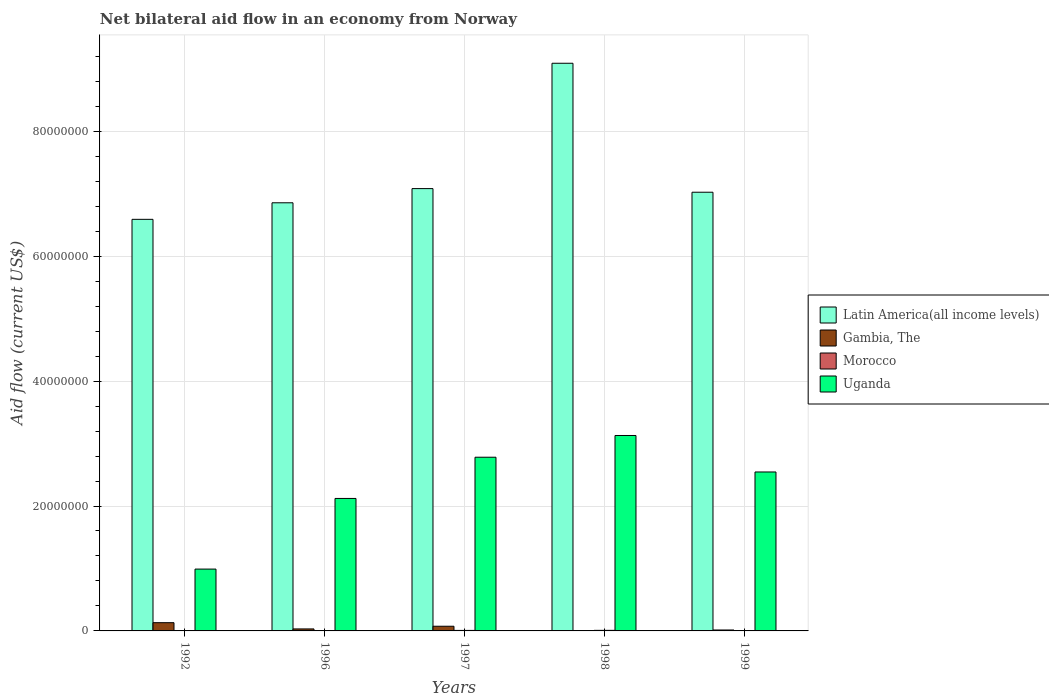How many different coloured bars are there?
Make the answer very short. 4. How many bars are there on the 1st tick from the left?
Provide a short and direct response. 4. How many bars are there on the 2nd tick from the right?
Give a very brief answer. 3. What is the label of the 4th group of bars from the left?
Offer a terse response. 1998. What is the net bilateral aid flow in Uganda in 1996?
Your answer should be compact. 2.12e+07. Across all years, what is the maximum net bilateral aid flow in Gambia, The?
Provide a succinct answer. 1.32e+06. Across all years, what is the minimum net bilateral aid flow in Uganda?
Make the answer very short. 9.90e+06. In which year was the net bilateral aid flow in Uganda maximum?
Make the answer very short. 1998. What is the total net bilateral aid flow in Uganda in the graph?
Provide a short and direct response. 1.16e+08. What is the difference between the net bilateral aid flow in Uganda in 1992 and that in 1996?
Offer a very short reply. -1.13e+07. What is the difference between the net bilateral aid flow in Latin America(all income levels) in 1998 and the net bilateral aid flow in Gambia, The in 1996?
Offer a very short reply. 9.06e+07. What is the average net bilateral aid flow in Gambia, The per year?
Provide a short and direct response. 5.08e+05. In the year 1996, what is the difference between the net bilateral aid flow in Uganda and net bilateral aid flow in Latin America(all income levels)?
Your answer should be compact. -4.73e+07. In how many years, is the net bilateral aid flow in Gambia, The greater than 80000000 US$?
Give a very brief answer. 0. What is the ratio of the net bilateral aid flow in Latin America(all income levels) in 1996 to that in 1998?
Offer a very short reply. 0.75. Is the difference between the net bilateral aid flow in Uganda in 1996 and 1999 greater than the difference between the net bilateral aid flow in Latin America(all income levels) in 1996 and 1999?
Your answer should be compact. No. What is the difference between the highest and the second highest net bilateral aid flow in Uganda?
Make the answer very short. 3.48e+06. What is the difference between the highest and the lowest net bilateral aid flow in Morocco?
Your answer should be very brief. 6.00e+04. In how many years, is the net bilateral aid flow in Latin America(all income levels) greater than the average net bilateral aid flow in Latin America(all income levels) taken over all years?
Your response must be concise. 1. Is the sum of the net bilateral aid flow in Morocco in 1996 and 1998 greater than the maximum net bilateral aid flow in Gambia, The across all years?
Make the answer very short. No. Is it the case that in every year, the sum of the net bilateral aid flow in Gambia, The and net bilateral aid flow in Morocco is greater than the net bilateral aid flow in Latin America(all income levels)?
Make the answer very short. No. How many years are there in the graph?
Keep it short and to the point. 5. Does the graph contain any zero values?
Offer a very short reply. Yes. Where does the legend appear in the graph?
Keep it short and to the point. Center right. What is the title of the graph?
Give a very brief answer. Net bilateral aid flow in an economy from Norway. What is the label or title of the X-axis?
Your answer should be very brief. Years. What is the Aid flow (current US$) of Latin America(all income levels) in 1992?
Offer a very short reply. 6.59e+07. What is the Aid flow (current US$) in Gambia, The in 1992?
Ensure brevity in your answer.  1.32e+06. What is the Aid flow (current US$) of Uganda in 1992?
Your answer should be very brief. 9.90e+06. What is the Aid flow (current US$) of Latin America(all income levels) in 1996?
Your answer should be compact. 6.86e+07. What is the Aid flow (current US$) in Uganda in 1996?
Your response must be concise. 2.12e+07. What is the Aid flow (current US$) of Latin America(all income levels) in 1997?
Provide a short and direct response. 7.08e+07. What is the Aid flow (current US$) of Gambia, The in 1997?
Provide a short and direct response. 7.50e+05. What is the Aid flow (current US$) of Uganda in 1997?
Your response must be concise. 2.78e+07. What is the Aid flow (current US$) of Latin America(all income levels) in 1998?
Your answer should be very brief. 9.09e+07. What is the Aid flow (current US$) in Gambia, The in 1998?
Give a very brief answer. 0. What is the Aid flow (current US$) of Morocco in 1998?
Give a very brief answer. 9.00e+04. What is the Aid flow (current US$) of Uganda in 1998?
Offer a very short reply. 3.13e+07. What is the Aid flow (current US$) of Latin America(all income levels) in 1999?
Offer a terse response. 7.02e+07. What is the Aid flow (current US$) of Uganda in 1999?
Your answer should be compact. 2.54e+07. Across all years, what is the maximum Aid flow (current US$) in Latin America(all income levels)?
Your answer should be very brief. 9.09e+07. Across all years, what is the maximum Aid flow (current US$) of Gambia, The?
Make the answer very short. 1.32e+06. Across all years, what is the maximum Aid flow (current US$) of Morocco?
Make the answer very short. 9.00e+04. Across all years, what is the maximum Aid flow (current US$) in Uganda?
Offer a terse response. 3.13e+07. Across all years, what is the minimum Aid flow (current US$) of Latin America(all income levels)?
Your response must be concise. 6.59e+07. Across all years, what is the minimum Aid flow (current US$) in Gambia, The?
Offer a terse response. 0. Across all years, what is the minimum Aid flow (current US$) of Uganda?
Offer a terse response. 9.90e+06. What is the total Aid flow (current US$) in Latin America(all income levels) in the graph?
Make the answer very short. 3.66e+08. What is the total Aid flow (current US$) in Gambia, The in the graph?
Your answer should be very brief. 2.54e+06. What is the total Aid flow (current US$) of Uganda in the graph?
Your answer should be compact. 1.16e+08. What is the difference between the Aid flow (current US$) in Latin America(all income levels) in 1992 and that in 1996?
Make the answer very short. -2.65e+06. What is the difference between the Aid flow (current US$) in Gambia, The in 1992 and that in 1996?
Provide a short and direct response. 1.00e+06. What is the difference between the Aid flow (current US$) in Uganda in 1992 and that in 1996?
Provide a succinct answer. -1.13e+07. What is the difference between the Aid flow (current US$) in Latin America(all income levels) in 1992 and that in 1997?
Keep it short and to the point. -4.92e+06. What is the difference between the Aid flow (current US$) of Gambia, The in 1992 and that in 1997?
Provide a short and direct response. 5.70e+05. What is the difference between the Aid flow (current US$) of Morocco in 1992 and that in 1997?
Ensure brevity in your answer.  -5.00e+04. What is the difference between the Aid flow (current US$) in Uganda in 1992 and that in 1997?
Give a very brief answer. -1.79e+07. What is the difference between the Aid flow (current US$) of Latin America(all income levels) in 1992 and that in 1998?
Ensure brevity in your answer.  -2.50e+07. What is the difference between the Aid flow (current US$) in Uganda in 1992 and that in 1998?
Keep it short and to the point. -2.14e+07. What is the difference between the Aid flow (current US$) of Latin America(all income levels) in 1992 and that in 1999?
Keep it short and to the point. -4.34e+06. What is the difference between the Aid flow (current US$) of Gambia, The in 1992 and that in 1999?
Offer a terse response. 1.17e+06. What is the difference between the Aid flow (current US$) in Morocco in 1992 and that in 1999?
Give a very brief answer. -10000. What is the difference between the Aid flow (current US$) of Uganda in 1992 and that in 1999?
Your answer should be very brief. -1.56e+07. What is the difference between the Aid flow (current US$) in Latin America(all income levels) in 1996 and that in 1997?
Make the answer very short. -2.27e+06. What is the difference between the Aid flow (current US$) of Gambia, The in 1996 and that in 1997?
Ensure brevity in your answer.  -4.30e+05. What is the difference between the Aid flow (current US$) in Morocco in 1996 and that in 1997?
Ensure brevity in your answer.  -3.00e+04. What is the difference between the Aid flow (current US$) of Uganda in 1996 and that in 1997?
Your answer should be very brief. -6.60e+06. What is the difference between the Aid flow (current US$) in Latin America(all income levels) in 1996 and that in 1998?
Keep it short and to the point. -2.23e+07. What is the difference between the Aid flow (current US$) of Uganda in 1996 and that in 1998?
Your answer should be compact. -1.01e+07. What is the difference between the Aid flow (current US$) in Latin America(all income levels) in 1996 and that in 1999?
Provide a succinct answer. -1.69e+06. What is the difference between the Aid flow (current US$) of Morocco in 1996 and that in 1999?
Offer a very short reply. 10000. What is the difference between the Aid flow (current US$) of Uganda in 1996 and that in 1999?
Make the answer very short. -4.24e+06. What is the difference between the Aid flow (current US$) in Latin America(all income levels) in 1997 and that in 1998?
Your response must be concise. -2.01e+07. What is the difference between the Aid flow (current US$) of Uganda in 1997 and that in 1998?
Your answer should be compact. -3.48e+06. What is the difference between the Aid flow (current US$) in Latin America(all income levels) in 1997 and that in 1999?
Your response must be concise. 5.80e+05. What is the difference between the Aid flow (current US$) of Morocco in 1997 and that in 1999?
Make the answer very short. 4.00e+04. What is the difference between the Aid flow (current US$) of Uganda in 1997 and that in 1999?
Make the answer very short. 2.36e+06. What is the difference between the Aid flow (current US$) of Latin America(all income levels) in 1998 and that in 1999?
Your answer should be compact. 2.06e+07. What is the difference between the Aid flow (current US$) in Uganda in 1998 and that in 1999?
Ensure brevity in your answer.  5.84e+06. What is the difference between the Aid flow (current US$) of Latin America(all income levels) in 1992 and the Aid flow (current US$) of Gambia, The in 1996?
Your answer should be very brief. 6.56e+07. What is the difference between the Aid flow (current US$) in Latin America(all income levels) in 1992 and the Aid flow (current US$) in Morocco in 1996?
Keep it short and to the point. 6.58e+07. What is the difference between the Aid flow (current US$) of Latin America(all income levels) in 1992 and the Aid flow (current US$) of Uganda in 1996?
Provide a short and direct response. 4.47e+07. What is the difference between the Aid flow (current US$) of Gambia, The in 1992 and the Aid flow (current US$) of Morocco in 1996?
Your answer should be compact. 1.27e+06. What is the difference between the Aid flow (current US$) in Gambia, The in 1992 and the Aid flow (current US$) in Uganda in 1996?
Your answer should be compact. -1.99e+07. What is the difference between the Aid flow (current US$) in Morocco in 1992 and the Aid flow (current US$) in Uganda in 1996?
Your answer should be compact. -2.12e+07. What is the difference between the Aid flow (current US$) of Latin America(all income levels) in 1992 and the Aid flow (current US$) of Gambia, The in 1997?
Offer a terse response. 6.52e+07. What is the difference between the Aid flow (current US$) in Latin America(all income levels) in 1992 and the Aid flow (current US$) in Morocco in 1997?
Give a very brief answer. 6.58e+07. What is the difference between the Aid flow (current US$) in Latin America(all income levels) in 1992 and the Aid flow (current US$) in Uganda in 1997?
Offer a terse response. 3.81e+07. What is the difference between the Aid flow (current US$) in Gambia, The in 1992 and the Aid flow (current US$) in Morocco in 1997?
Your answer should be very brief. 1.24e+06. What is the difference between the Aid flow (current US$) of Gambia, The in 1992 and the Aid flow (current US$) of Uganda in 1997?
Your response must be concise. -2.65e+07. What is the difference between the Aid flow (current US$) of Morocco in 1992 and the Aid flow (current US$) of Uganda in 1997?
Your response must be concise. -2.78e+07. What is the difference between the Aid flow (current US$) in Latin America(all income levels) in 1992 and the Aid flow (current US$) in Morocco in 1998?
Offer a terse response. 6.58e+07. What is the difference between the Aid flow (current US$) in Latin America(all income levels) in 1992 and the Aid flow (current US$) in Uganda in 1998?
Your response must be concise. 3.46e+07. What is the difference between the Aid flow (current US$) of Gambia, The in 1992 and the Aid flow (current US$) of Morocco in 1998?
Keep it short and to the point. 1.23e+06. What is the difference between the Aid flow (current US$) in Gambia, The in 1992 and the Aid flow (current US$) in Uganda in 1998?
Make the answer very short. -3.00e+07. What is the difference between the Aid flow (current US$) of Morocco in 1992 and the Aid flow (current US$) of Uganda in 1998?
Your answer should be compact. -3.13e+07. What is the difference between the Aid flow (current US$) in Latin America(all income levels) in 1992 and the Aid flow (current US$) in Gambia, The in 1999?
Your answer should be compact. 6.58e+07. What is the difference between the Aid flow (current US$) of Latin America(all income levels) in 1992 and the Aid flow (current US$) of Morocco in 1999?
Keep it short and to the point. 6.59e+07. What is the difference between the Aid flow (current US$) of Latin America(all income levels) in 1992 and the Aid flow (current US$) of Uganda in 1999?
Give a very brief answer. 4.04e+07. What is the difference between the Aid flow (current US$) in Gambia, The in 1992 and the Aid flow (current US$) in Morocco in 1999?
Your answer should be very brief. 1.28e+06. What is the difference between the Aid flow (current US$) of Gambia, The in 1992 and the Aid flow (current US$) of Uganda in 1999?
Your answer should be compact. -2.41e+07. What is the difference between the Aid flow (current US$) in Morocco in 1992 and the Aid flow (current US$) in Uganda in 1999?
Offer a very short reply. -2.54e+07. What is the difference between the Aid flow (current US$) of Latin America(all income levels) in 1996 and the Aid flow (current US$) of Gambia, The in 1997?
Offer a terse response. 6.78e+07. What is the difference between the Aid flow (current US$) of Latin America(all income levels) in 1996 and the Aid flow (current US$) of Morocco in 1997?
Make the answer very short. 6.85e+07. What is the difference between the Aid flow (current US$) of Latin America(all income levels) in 1996 and the Aid flow (current US$) of Uganda in 1997?
Provide a short and direct response. 4.07e+07. What is the difference between the Aid flow (current US$) in Gambia, The in 1996 and the Aid flow (current US$) in Uganda in 1997?
Keep it short and to the point. -2.75e+07. What is the difference between the Aid flow (current US$) in Morocco in 1996 and the Aid flow (current US$) in Uganda in 1997?
Your answer should be compact. -2.78e+07. What is the difference between the Aid flow (current US$) of Latin America(all income levels) in 1996 and the Aid flow (current US$) of Morocco in 1998?
Your response must be concise. 6.85e+07. What is the difference between the Aid flow (current US$) of Latin America(all income levels) in 1996 and the Aid flow (current US$) of Uganda in 1998?
Offer a terse response. 3.73e+07. What is the difference between the Aid flow (current US$) in Gambia, The in 1996 and the Aid flow (current US$) in Morocco in 1998?
Keep it short and to the point. 2.30e+05. What is the difference between the Aid flow (current US$) in Gambia, The in 1996 and the Aid flow (current US$) in Uganda in 1998?
Your answer should be very brief. -3.10e+07. What is the difference between the Aid flow (current US$) of Morocco in 1996 and the Aid flow (current US$) of Uganda in 1998?
Keep it short and to the point. -3.12e+07. What is the difference between the Aid flow (current US$) of Latin America(all income levels) in 1996 and the Aid flow (current US$) of Gambia, The in 1999?
Offer a terse response. 6.84e+07. What is the difference between the Aid flow (current US$) of Latin America(all income levels) in 1996 and the Aid flow (current US$) of Morocco in 1999?
Offer a very short reply. 6.85e+07. What is the difference between the Aid flow (current US$) of Latin America(all income levels) in 1996 and the Aid flow (current US$) of Uganda in 1999?
Ensure brevity in your answer.  4.31e+07. What is the difference between the Aid flow (current US$) of Gambia, The in 1996 and the Aid flow (current US$) of Uganda in 1999?
Provide a short and direct response. -2.51e+07. What is the difference between the Aid flow (current US$) of Morocco in 1996 and the Aid flow (current US$) of Uganda in 1999?
Offer a very short reply. -2.54e+07. What is the difference between the Aid flow (current US$) of Latin America(all income levels) in 1997 and the Aid flow (current US$) of Morocco in 1998?
Ensure brevity in your answer.  7.07e+07. What is the difference between the Aid flow (current US$) of Latin America(all income levels) in 1997 and the Aid flow (current US$) of Uganda in 1998?
Your answer should be compact. 3.95e+07. What is the difference between the Aid flow (current US$) in Gambia, The in 1997 and the Aid flow (current US$) in Morocco in 1998?
Ensure brevity in your answer.  6.60e+05. What is the difference between the Aid flow (current US$) of Gambia, The in 1997 and the Aid flow (current US$) of Uganda in 1998?
Your answer should be very brief. -3.05e+07. What is the difference between the Aid flow (current US$) in Morocco in 1997 and the Aid flow (current US$) in Uganda in 1998?
Provide a short and direct response. -3.12e+07. What is the difference between the Aid flow (current US$) of Latin America(all income levels) in 1997 and the Aid flow (current US$) of Gambia, The in 1999?
Keep it short and to the point. 7.07e+07. What is the difference between the Aid flow (current US$) of Latin America(all income levels) in 1997 and the Aid flow (current US$) of Morocco in 1999?
Ensure brevity in your answer.  7.08e+07. What is the difference between the Aid flow (current US$) in Latin America(all income levels) in 1997 and the Aid flow (current US$) in Uganda in 1999?
Your answer should be compact. 4.54e+07. What is the difference between the Aid flow (current US$) in Gambia, The in 1997 and the Aid flow (current US$) in Morocco in 1999?
Your response must be concise. 7.10e+05. What is the difference between the Aid flow (current US$) of Gambia, The in 1997 and the Aid flow (current US$) of Uganda in 1999?
Keep it short and to the point. -2.47e+07. What is the difference between the Aid flow (current US$) of Morocco in 1997 and the Aid flow (current US$) of Uganda in 1999?
Keep it short and to the point. -2.54e+07. What is the difference between the Aid flow (current US$) of Latin America(all income levels) in 1998 and the Aid flow (current US$) of Gambia, The in 1999?
Provide a short and direct response. 9.07e+07. What is the difference between the Aid flow (current US$) in Latin America(all income levels) in 1998 and the Aid flow (current US$) in Morocco in 1999?
Offer a very short reply. 9.08e+07. What is the difference between the Aid flow (current US$) of Latin America(all income levels) in 1998 and the Aid flow (current US$) of Uganda in 1999?
Keep it short and to the point. 6.54e+07. What is the difference between the Aid flow (current US$) in Morocco in 1998 and the Aid flow (current US$) in Uganda in 1999?
Your answer should be compact. -2.54e+07. What is the average Aid flow (current US$) of Latin America(all income levels) per year?
Provide a short and direct response. 7.33e+07. What is the average Aid flow (current US$) in Gambia, The per year?
Provide a succinct answer. 5.08e+05. What is the average Aid flow (current US$) in Morocco per year?
Make the answer very short. 5.80e+04. What is the average Aid flow (current US$) of Uganda per year?
Ensure brevity in your answer.  2.31e+07. In the year 1992, what is the difference between the Aid flow (current US$) in Latin America(all income levels) and Aid flow (current US$) in Gambia, The?
Your answer should be compact. 6.46e+07. In the year 1992, what is the difference between the Aid flow (current US$) in Latin America(all income levels) and Aid flow (current US$) in Morocco?
Your response must be concise. 6.59e+07. In the year 1992, what is the difference between the Aid flow (current US$) of Latin America(all income levels) and Aid flow (current US$) of Uganda?
Your answer should be compact. 5.60e+07. In the year 1992, what is the difference between the Aid flow (current US$) in Gambia, The and Aid flow (current US$) in Morocco?
Give a very brief answer. 1.29e+06. In the year 1992, what is the difference between the Aid flow (current US$) in Gambia, The and Aid flow (current US$) in Uganda?
Provide a short and direct response. -8.58e+06. In the year 1992, what is the difference between the Aid flow (current US$) in Morocco and Aid flow (current US$) in Uganda?
Provide a short and direct response. -9.87e+06. In the year 1996, what is the difference between the Aid flow (current US$) of Latin America(all income levels) and Aid flow (current US$) of Gambia, The?
Provide a short and direct response. 6.82e+07. In the year 1996, what is the difference between the Aid flow (current US$) in Latin America(all income levels) and Aid flow (current US$) in Morocco?
Your response must be concise. 6.85e+07. In the year 1996, what is the difference between the Aid flow (current US$) in Latin America(all income levels) and Aid flow (current US$) in Uganda?
Your answer should be very brief. 4.73e+07. In the year 1996, what is the difference between the Aid flow (current US$) in Gambia, The and Aid flow (current US$) in Uganda?
Your response must be concise. -2.09e+07. In the year 1996, what is the difference between the Aid flow (current US$) in Morocco and Aid flow (current US$) in Uganda?
Provide a succinct answer. -2.12e+07. In the year 1997, what is the difference between the Aid flow (current US$) in Latin America(all income levels) and Aid flow (current US$) in Gambia, The?
Your answer should be compact. 7.01e+07. In the year 1997, what is the difference between the Aid flow (current US$) in Latin America(all income levels) and Aid flow (current US$) in Morocco?
Offer a terse response. 7.07e+07. In the year 1997, what is the difference between the Aid flow (current US$) in Latin America(all income levels) and Aid flow (current US$) in Uganda?
Provide a short and direct response. 4.30e+07. In the year 1997, what is the difference between the Aid flow (current US$) in Gambia, The and Aid flow (current US$) in Morocco?
Your answer should be compact. 6.70e+05. In the year 1997, what is the difference between the Aid flow (current US$) in Gambia, The and Aid flow (current US$) in Uganda?
Give a very brief answer. -2.71e+07. In the year 1997, what is the difference between the Aid flow (current US$) of Morocco and Aid flow (current US$) of Uganda?
Give a very brief answer. -2.77e+07. In the year 1998, what is the difference between the Aid flow (current US$) in Latin America(all income levels) and Aid flow (current US$) in Morocco?
Make the answer very short. 9.08e+07. In the year 1998, what is the difference between the Aid flow (current US$) of Latin America(all income levels) and Aid flow (current US$) of Uganda?
Provide a short and direct response. 5.96e+07. In the year 1998, what is the difference between the Aid flow (current US$) of Morocco and Aid flow (current US$) of Uganda?
Provide a short and direct response. -3.12e+07. In the year 1999, what is the difference between the Aid flow (current US$) of Latin America(all income levels) and Aid flow (current US$) of Gambia, The?
Provide a short and direct response. 7.01e+07. In the year 1999, what is the difference between the Aid flow (current US$) of Latin America(all income levels) and Aid flow (current US$) of Morocco?
Offer a terse response. 7.02e+07. In the year 1999, what is the difference between the Aid flow (current US$) of Latin America(all income levels) and Aid flow (current US$) of Uganda?
Make the answer very short. 4.48e+07. In the year 1999, what is the difference between the Aid flow (current US$) of Gambia, The and Aid flow (current US$) of Uganda?
Make the answer very short. -2.53e+07. In the year 1999, what is the difference between the Aid flow (current US$) of Morocco and Aid flow (current US$) of Uganda?
Offer a terse response. -2.54e+07. What is the ratio of the Aid flow (current US$) in Latin America(all income levels) in 1992 to that in 1996?
Ensure brevity in your answer.  0.96. What is the ratio of the Aid flow (current US$) of Gambia, The in 1992 to that in 1996?
Ensure brevity in your answer.  4.12. What is the ratio of the Aid flow (current US$) in Morocco in 1992 to that in 1996?
Make the answer very short. 0.6. What is the ratio of the Aid flow (current US$) in Uganda in 1992 to that in 1996?
Offer a very short reply. 0.47. What is the ratio of the Aid flow (current US$) in Latin America(all income levels) in 1992 to that in 1997?
Offer a very short reply. 0.93. What is the ratio of the Aid flow (current US$) in Gambia, The in 1992 to that in 1997?
Give a very brief answer. 1.76. What is the ratio of the Aid flow (current US$) in Morocco in 1992 to that in 1997?
Provide a succinct answer. 0.38. What is the ratio of the Aid flow (current US$) of Uganda in 1992 to that in 1997?
Provide a short and direct response. 0.36. What is the ratio of the Aid flow (current US$) in Latin America(all income levels) in 1992 to that in 1998?
Your answer should be compact. 0.73. What is the ratio of the Aid flow (current US$) in Morocco in 1992 to that in 1998?
Offer a terse response. 0.33. What is the ratio of the Aid flow (current US$) in Uganda in 1992 to that in 1998?
Give a very brief answer. 0.32. What is the ratio of the Aid flow (current US$) of Latin America(all income levels) in 1992 to that in 1999?
Ensure brevity in your answer.  0.94. What is the ratio of the Aid flow (current US$) in Gambia, The in 1992 to that in 1999?
Ensure brevity in your answer.  8.8. What is the ratio of the Aid flow (current US$) in Morocco in 1992 to that in 1999?
Offer a terse response. 0.75. What is the ratio of the Aid flow (current US$) in Uganda in 1992 to that in 1999?
Your answer should be compact. 0.39. What is the ratio of the Aid flow (current US$) in Latin America(all income levels) in 1996 to that in 1997?
Offer a very short reply. 0.97. What is the ratio of the Aid flow (current US$) of Gambia, The in 1996 to that in 1997?
Provide a succinct answer. 0.43. What is the ratio of the Aid flow (current US$) of Uganda in 1996 to that in 1997?
Give a very brief answer. 0.76. What is the ratio of the Aid flow (current US$) of Latin America(all income levels) in 1996 to that in 1998?
Make the answer very short. 0.75. What is the ratio of the Aid flow (current US$) in Morocco in 1996 to that in 1998?
Make the answer very short. 0.56. What is the ratio of the Aid flow (current US$) of Uganda in 1996 to that in 1998?
Your answer should be very brief. 0.68. What is the ratio of the Aid flow (current US$) in Latin America(all income levels) in 1996 to that in 1999?
Offer a very short reply. 0.98. What is the ratio of the Aid flow (current US$) of Gambia, The in 1996 to that in 1999?
Offer a terse response. 2.13. What is the ratio of the Aid flow (current US$) in Uganda in 1996 to that in 1999?
Your response must be concise. 0.83. What is the ratio of the Aid flow (current US$) in Latin America(all income levels) in 1997 to that in 1998?
Give a very brief answer. 0.78. What is the ratio of the Aid flow (current US$) of Morocco in 1997 to that in 1998?
Give a very brief answer. 0.89. What is the ratio of the Aid flow (current US$) of Uganda in 1997 to that in 1998?
Provide a succinct answer. 0.89. What is the ratio of the Aid flow (current US$) in Latin America(all income levels) in 1997 to that in 1999?
Your answer should be very brief. 1.01. What is the ratio of the Aid flow (current US$) in Uganda in 1997 to that in 1999?
Your answer should be very brief. 1.09. What is the ratio of the Aid flow (current US$) of Latin America(all income levels) in 1998 to that in 1999?
Give a very brief answer. 1.29. What is the ratio of the Aid flow (current US$) of Morocco in 1998 to that in 1999?
Ensure brevity in your answer.  2.25. What is the ratio of the Aid flow (current US$) of Uganda in 1998 to that in 1999?
Your answer should be compact. 1.23. What is the difference between the highest and the second highest Aid flow (current US$) in Latin America(all income levels)?
Your answer should be very brief. 2.01e+07. What is the difference between the highest and the second highest Aid flow (current US$) in Gambia, The?
Your answer should be compact. 5.70e+05. What is the difference between the highest and the second highest Aid flow (current US$) of Uganda?
Give a very brief answer. 3.48e+06. What is the difference between the highest and the lowest Aid flow (current US$) of Latin America(all income levels)?
Your answer should be very brief. 2.50e+07. What is the difference between the highest and the lowest Aid flow (current US$) in Gambia, The?
Provide a short and direct response. 1.32e+06. What is the difference between the highest and the lowest Aid flow (current US$) of Morocco?
Keep it short and to the point. 6.00e+04. What is the difference between the highest and the lowest Aid flow (current US$) of Uganda?
Make the answer very short. 2.14e+07. 